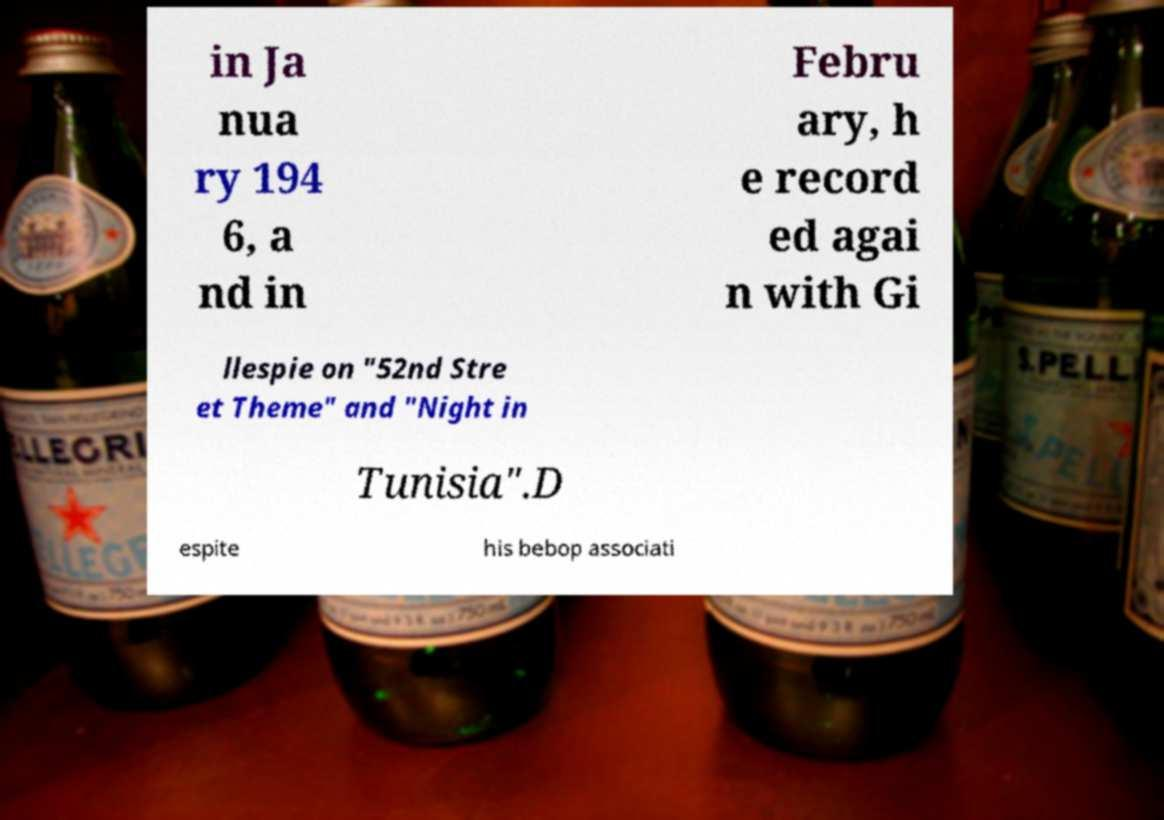Could you assist in decoding the text presented in this image and type it out clearly? in Ja nua ry 194 6, a nd in Febru ary, h e record ed agai n with Gi llespie on "52nd Stre et Theme" and "Night in Tunisia".D espite his bebop associati 